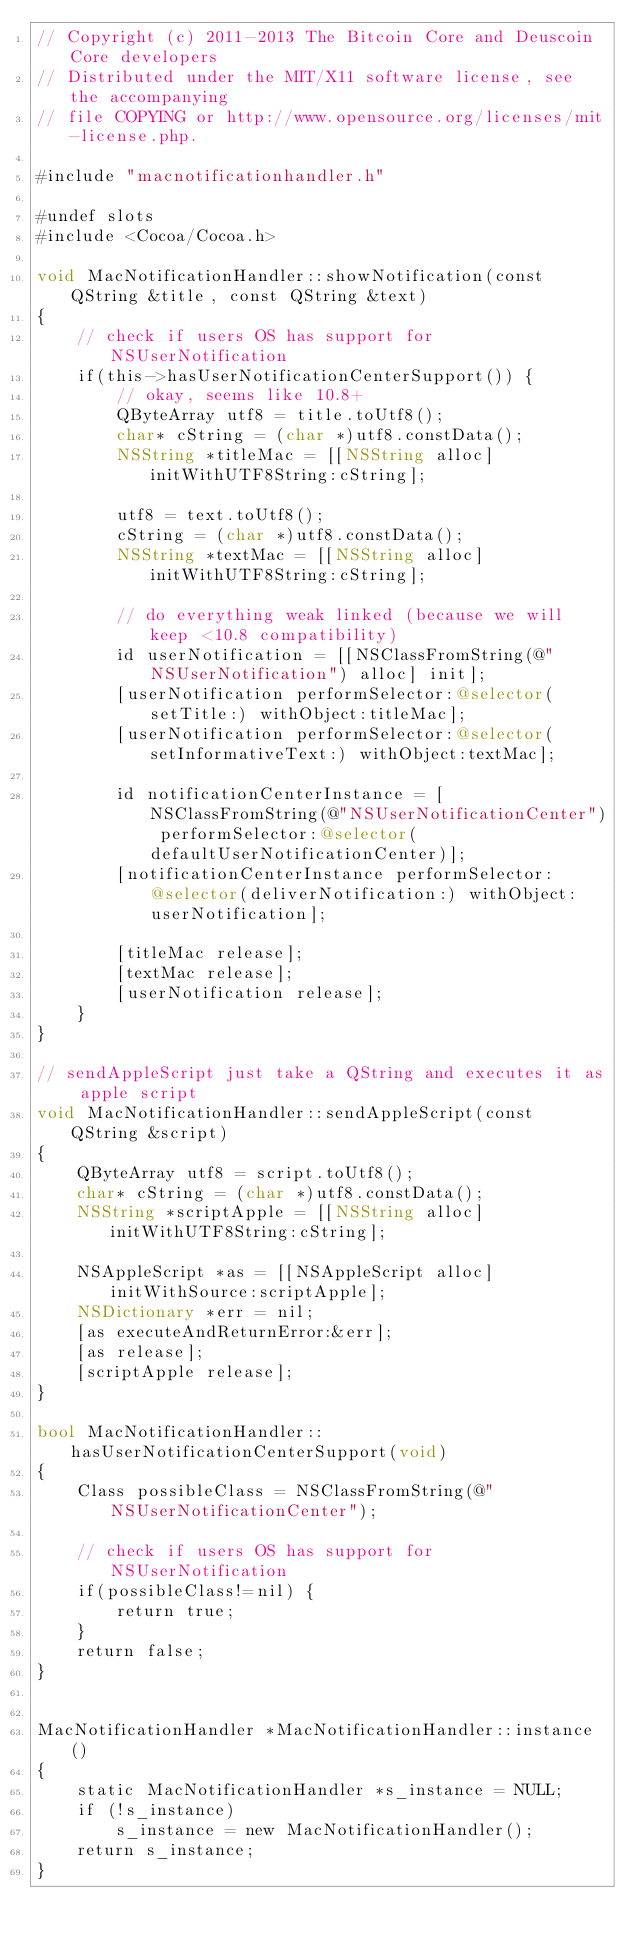Convert code to text. <code><loc_0><loc_0><loc_500><loc_500><_ObjectiveC_>// Copyright (c) 2011-2013 The Bitcoin Core and Deuscoin Core developers
// Distributed under the MIT/X11 software license, see the accompanying
// file COPYING or http://www.opensource.org/licenses/mit-license.php.

#include "macnotificationhandler.h"

#undef slots
#include <Cocoa/Cocoa.h>

void MacNotificationHandler::showNotification(const QString &title, const QString &text)
{
    // check if users OS has support for NSUserNotification
    if(this->hasUserNotificationCenterSupport()) {
        // okay, seems like 10.8+
        QByteArray utf8 = title.toUtf8();
        char* cString = (char *)utf8.constData();
        NSString *titleMac = [[NSString alloc] initWithUTF8String:cString];

        utf8 = text.toUtf8();
        cString = (char *)utf8.constData();
        NSString *textMac = [[NSString alloc] initWithUTF8String:cString];

        // do everything weak linked (because we will keep <10.8 compatibility)
        id userNotification = [[NSClassFromString(@"NSUserNotification") alloc] init];
        [userNotification performSelector:@selector(setTitle:) withObject:titleMac];
        [userNotification performSelector:@selector(setInformativeText:) withObject:textMac];

        id notificationCenterInstance = [NSClassFromString(@"NSUserNotificationCenter") performSelector:@selector(defaultUserNotificationCenter)];
        [notificationCenterInstance performSelector:@selector(deliverNotification:) withObject:userNotification];

        [titleMac release];
        [textMac release];
        [userNotification release];
    }
}

// sendAppleScript just take a QString and executes it as apple script
void MacNotificationHandler::sendAppleScript(const QString &script)
{
    QByteArray utf8 = script.toUtf8();
    char* cString = (char *)utf8.constData();
    NSString *scriptApple = [[NSString alloc] initWithUTF8String:cString];

    NSAppleScript *as = [[NSAppleScript alloc] initWithSource:scriptApple];
    NSDictionary *err = nil;
    [as executeAndReturnError:&err];
    [as release];
    [scriptApple release];
}

bool MacNotificationHandler::hasUserNotificationCenterSupport(void)
{
    Class possibleClass = NSClassFromString(@"NSUserNotificationCenter");

    // check if users OS has support for NSUserNotification
    if(possibleClass!=nil) {
        return true;
    }
    return false;
}


MacNotificationHandler *MacNotificationHandler::instance()
{
    static MacNotificationHandler *s_instance = NULL;
    if (!s_instance)
        s_instance = new MacNotificationHandler();
    return s_instance;
}
</code> 